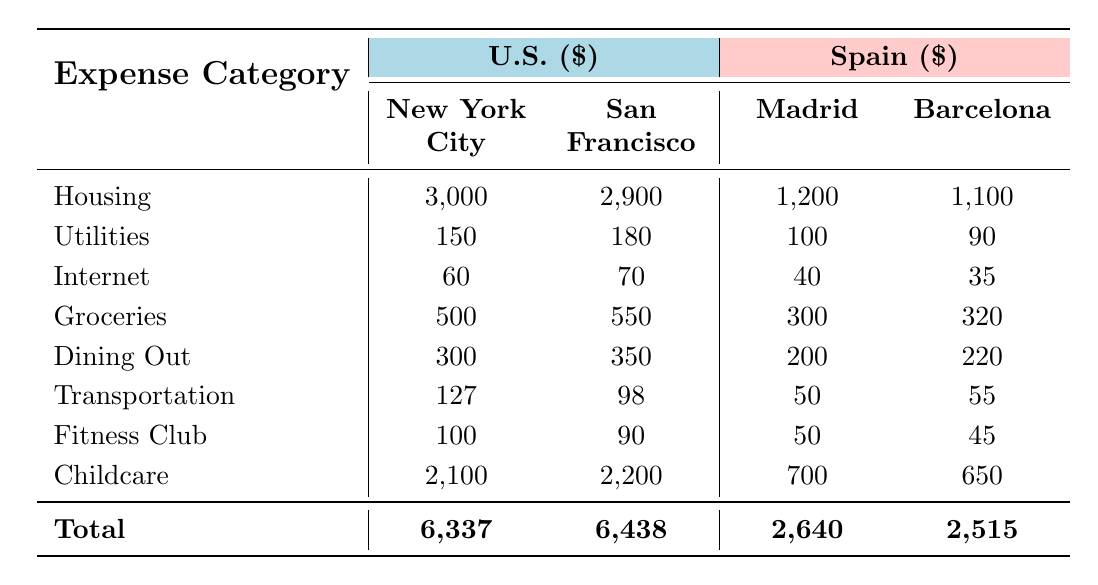What is the highest housing cost in the U.S.? The highest housing cost is in New York City, which is $3,000.
Answer: 3000 What is the average utility cost in Spain? To find the average utility cost in Spain, we sum the utility costs of all cities: 100 (Madrid) + 90 (Barcelona) + 70 (Valencia) + 60 (Seville) = 320. Then we divide by the number of cities (4): 320 / 4 = 80.
Answer: 80 Is the dining out cost in Barcelona higher than in Seville? The dining out cost in Barcelona is $220, while in Seville it is $150; hence, yes, Barcelona is higher.
Answer: Yes What is the difference in total costs between San Francisco and Madrid? The total cost for San Francisco is $6,438, and for Madrid, it is $2,640. The difference is calculated by subtracting Madrid's cost from San Francisco's: 6,438 - 2,640 = 3,798.
Answer: 3798 Which city has the lowest grocery cost? The lowest grocery cost is found in Seville, which is $240.
Answer: 240 Are transportation costs in Austin lower than in Valencia? Transportation cost in Austin is $80 and in Valencia it is $45; so the cost in Austin is higher, making this statement false.
Answer: No What is the total cost of living for Chicago? The total cost for Chicago is calculated by adding all respective costs: 1,600 (housing) + 140 (utilities) + 55 (internet) + 450 (groceries) + 280 (dining out) + 105 (transportation) + 80 (fitness club) + 1,500 (childcare) = 4,210.
Answer: 4210 How much cheaper is it to live in Valencia compared to New York City? To find this, compare the total costs. The total cost in Valencia is $2,640, while in New York City is $6,337. The difference is: 6,337 - 2,640 = 3,697.
Answer: 3697 What is the combined cost of internet and dining out in Madrid? The combined cost in Madrid is $40 (internet) + $200 (dining out) = $240.
Answer: 240 